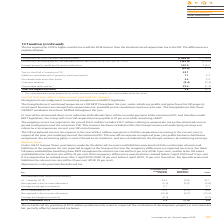According to Intu Properties's financial document, What does the ongoing current tax expense in the year of  £16.0 million include? includes £15.7 million relating to corporation tax on the estimated current period underpayment of the minimum PID. The document states: "current tax expense in the year of £16.0 million includes £15.7 million relating to corporation tax on the estimated current period underpayment of th..." Also, What is the UK corporation tax payable incurred by the Group? According to the financial document, 19 per cent. The relevant text states: "he Group will incur UK corporation tax payable at 19 per cent while remaining a REIT...." Also, What does the UK exceptional current tax expense in the year of  £6.4 million represent? the corporation tax arising in the current year in respect of the prior year underpayment of the minimum PID. The document states: "se in the year of £6.4 million represents in full the corporation tax arising in the current year in respect of the prior year underpayment of the min..." Also, can you calculate: What is the percentage change in the loss before tax, joint ventures and associates from 2018 to 2019? To answer this question, I need to perform calculations using the financial data. The calculation is: (1,856.8-1,139.6)/1,139.6, which equals 62.93 (percentage). This is based on the information: "ore tax, joint ventures and associates (1,856.8) (1,139.6) Loss before tax, joint ventures and associates (1,856.8) (1,139.6)..." The key data points involved are: 1,139.6, 1,856.8. Also, can you calculate: What is the percentage change in the loss before tax multiplied by the standard rate of tax in the UK of 19% from 2018 to 2019? To answer this question, I need to perform calculations using the financial data. The calculation is: (352.8-216.6)/216.6, which equals 62.88 (percentage). This is based on the information: "rate of tax in the UK of 19% (2018: 19%) (352.8) (216.6) tandard rate of tax in the UK of 19% (2018: 19%) (352.8) (216.6)..." The key data points involved are: 216.6, 352.8. Also, can you calculate: What is the percentage change in the exempt property rental profits and revaluations from 2018 to 2019? To answer this question, I need to perform calculations using the financial data. The calculation is: (307.0-214.9)/214.9, which equals 42.86 (percentage). This is based on the information: "pt property rental profits and revaluations 307.0 214.9 Exempt property rental profits and revaluations 307.0 214.9..." The key data points involved are: 214.9, 307.0. 